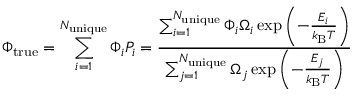<formula> <loc_0><loc_0><loc_500><loc_500>\Phi _ { t r u e } = \sum _ { i = 1 } ^ { N _ { u n i q u e } } \Phi _ { i } P _ { i } = \frac { \sum _ { i = 1 } ^ { N _ { u n i q u e } } \Phi _ { i } \Omega _ { i } \exp { \left ( - \frac { E _ { i } } { k _ { B } T } \right ) } } { \sum _ { j = 1 } ^ { N _ { u n i q u e } } \Omega _ { j } \exp { \left ( - \frac { E _ { j } } { k _ { B } T } \right ) } }</formula> 